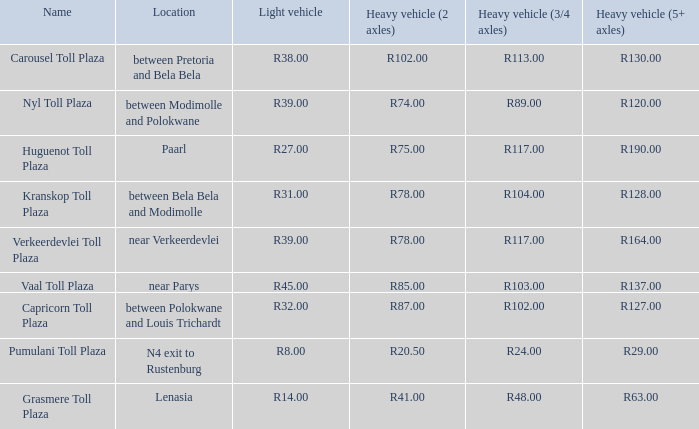What is the toll for light vehicles at the plaza between bela bela and modimolle? R31.00. 